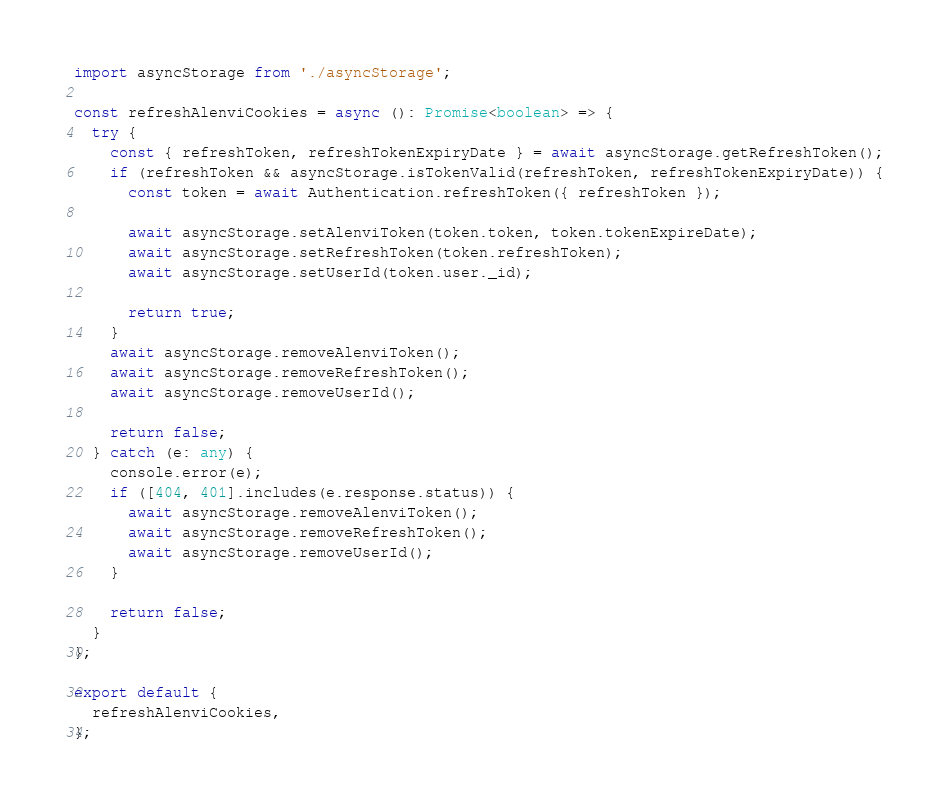Convert code to text. <code><loc_0><loc_0><loc_500><loc_500><_TypeScript_>import asyncStorage from './asyncStorage';

const refreshAlenviCookies = async (): Promise<boolean> => {
  try {
    const { refreshToken, refreshTokenExpiryDate } = await asyncStorage.getRefreshToken();
    if (refreshToken && asyncStorage.isTokenValid(refreshToken, refreshTokenExpiryDate)) {
      const token = await Authentication.refreshToken({ refreshToken });

      await asyncStorage.setAlenviToken(token.token, token.tokenExpireDate);
      await asyncStorage.setRefreshToken(token.refreshToken);
      await asyncStorage.setUserId(token.user._id);

      return true;
    }
    await asyncStorage.removeAlenviToken();
    await asyncStorage.removeRefreshToken();
    await asyncStorage.removeUserId();

    return false;
  } catch (e: any) {
    console.error(e);
    if ([404, 401].includes(e.response.status)) {
      await asyncStorage.removeAlenviToken();
      await asyncStorage.removeRefreshToken();
      await asyncStorage.removeUserId();
    }

    return false;
  }
};

export default {
  refreshAlenviCookies,
};
</code> 